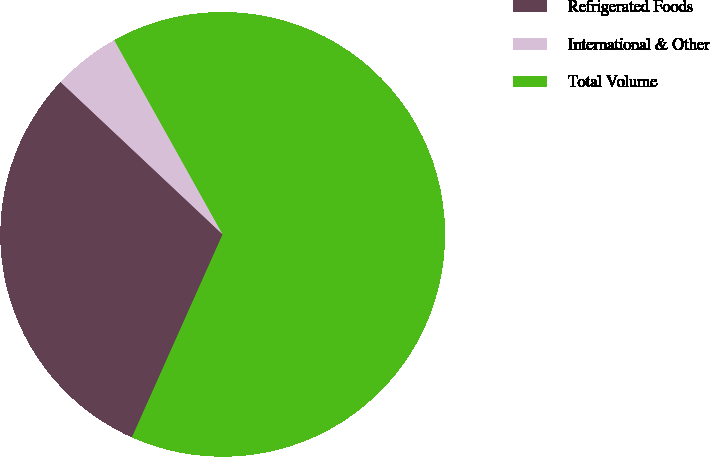<chart> <loc_0><loc_0><loc_500><loc_500><pie_chart><fcel>Refrigerated Foods<fcel>International & Other<fcel>Total Volume<nl><fcel>30.32%<fcel>4.89%<fcel>64.78%<nl></chart> 